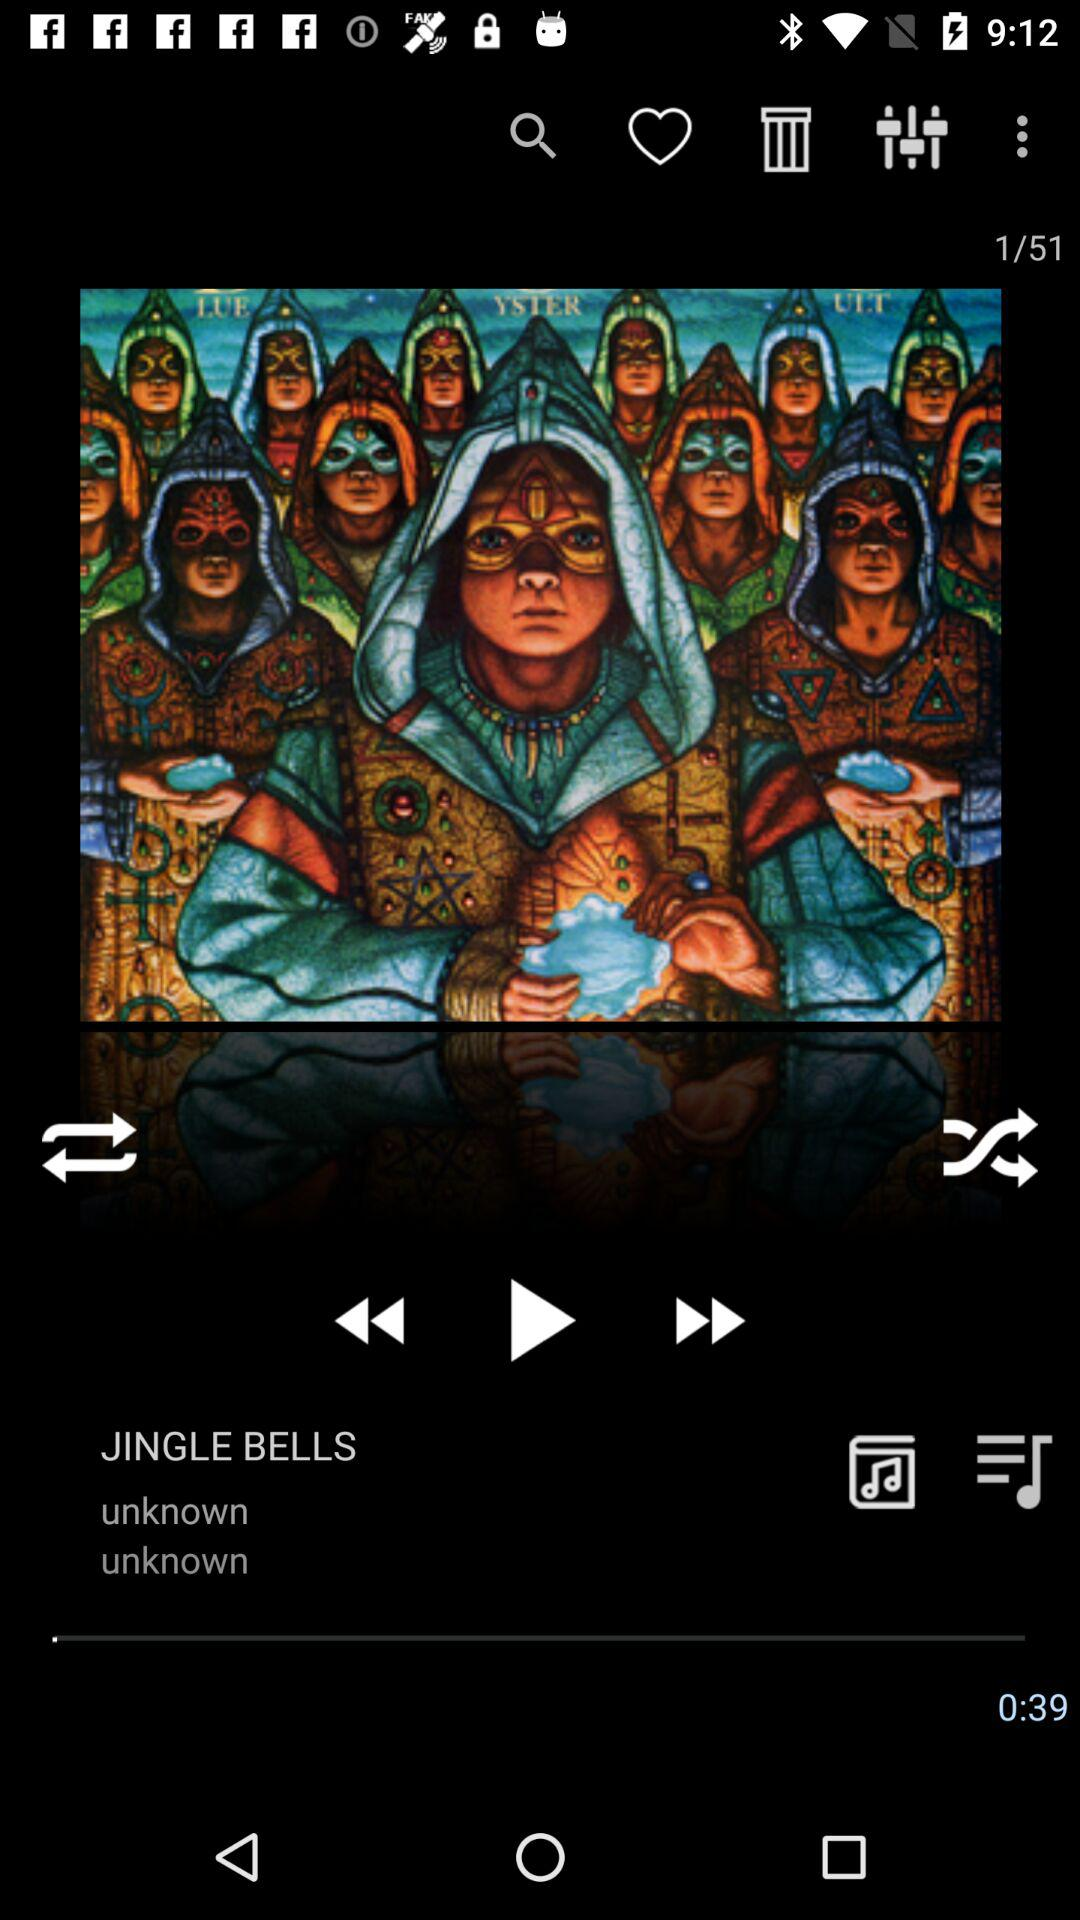Which audio files were placed in the trash?
When the provided information is insufficient, respond with <no answer>. <no answer> 